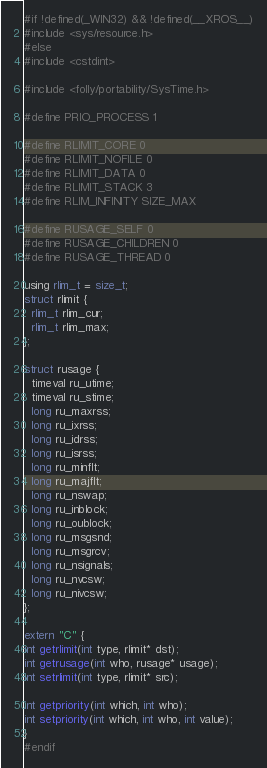<code> <loc_0><loc_0><loc_500><loc_500><_C_>
#if !defined(_WIN32) && !defined(__XROS__)
#include <sys/resource.h>
#else
#include <cstdint>

#include <folly/portability/SysTime.h>

#define PRIO_PROCESS 1

#define RLIMIT_CORE 0
#define RLIMIT_NOFILE 0
#define RLIMIT_DATA 0
#define RLIMIT_STACK 3
#define RLIM_INFINITY SIZE_MAX

#define RUSAGE_SELF 0
#define RUSAGE_CHILDREN 0
#define RUSAGE_THREAD 0

using rlim_t = size_t;
struct rlimit {
  rlim_t rlim_cur;
  rlim_t rlim_max;
};

struct rusage {
  timeval ru_utime;
  timeval ru_stime;
  long ru_maxrss;
  long ru_ixrss;
  long ru_idrss;
  long ru_isrss;
  long ru_minflt;
  long ru_majflt;
  long ru_nswap;
  long ru_inblock;
  long ru_oublock;
  long ru_msgsnd;
  long ru_msgrcv;
  long ru_nsignals;
  long ru_nvcsw;
  long ru_nivcsw;
};

extern "C" {
int getrlimit(int type, rlimit* dst);
int getrusage(int who, rusage* usage);
int setrlimit(int type, rlimit* src);

int getpriority(int which, int who);
int setpriority(int which, int who, int value);
}
#endif
</code> 